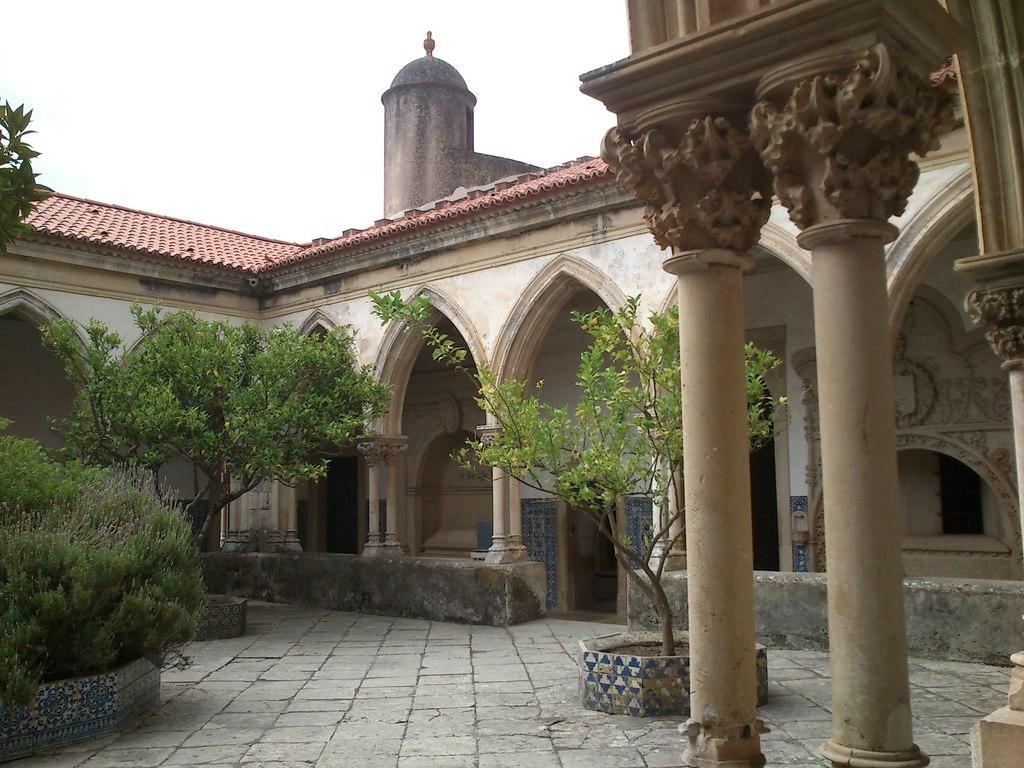Could you give a brief overview of what you see in this image? In this image in the center there is a building and in the foreground there are pillars, and also there are some plants and flower pots. At the top there is roof, and at the top of the image there is sky. At the bottom there is floor. 